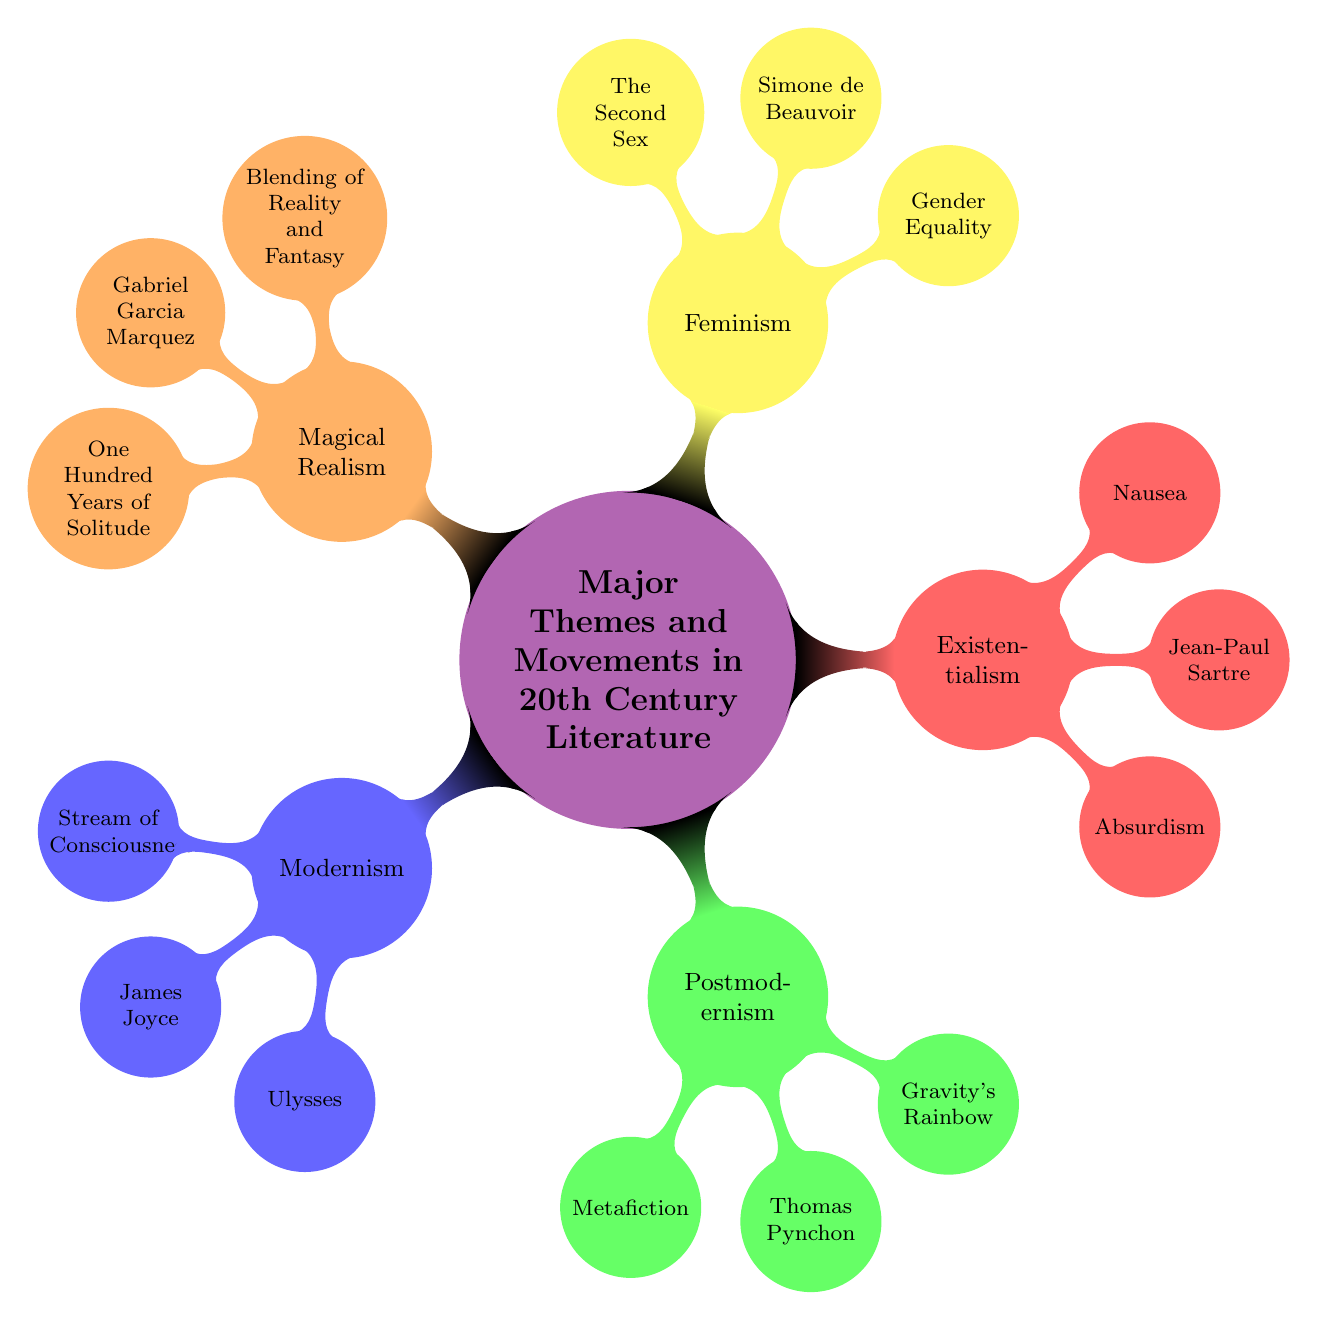What are the key features of Modernism? The diagram lists key features under the Modernism node, which include "Stream of Consciousness," "Fragmentation," and "Narrative Ambiguity."
Answer: Stream of Consciousness, Fragmentation, Narrative Ambiguity Who is a notable author of Postmodernism? The diagram shows that notable authors under Postmodernism include "Thomas Pynchon," "Don DeLillo," and "Kurt Vonnegut." Therefore, any of these can be a correct answer.
Answer: Thomas Pynchon What is a major work associated with Feminism? Within the Feminism node, the diagram lists major works which include "The Second Sex," "The Bell Jar," and "Beloved." Any of these would be a valid answer.
Answer: The Second Sex How many key features are listed under Existentialism? The Existentialism node features three key points: "Absurdism," "Freedom and Choice," and "Alienation." Therefore, the answer is determined by counting these features.
Answer: 3 Which author is associated with Magical Realism? By examining the Magical Realism node, one can see mentioned authors including "Gabriel Garcia Marquez," "Isabel Allende," and "Salman Rushdie." Therefore, any of these authors is correct.
Answer: Gabriel Garcia Marquez What core theme links Jean-Paul Sartre and his works? By focusing on the Existentialism node and identifying Jean-Paul Sartre, we find his prominent work listed as "Nausea," which connects back to his themes of Absurdism and alienation. Thus, it's primarily centered around his philosophical perspectives.
Answer: Absurdism What is the relationship between Modernism’s key features and its notable authors? Understanding this asks for combining information: Modernism includes features like "Stream of Consciousness" and is represented by authors like "James Joyce" who is critically known for using such techniques in "Ulysses." Thus, the connection lies in how these authors embody the features through their works.
Answer: James Joyce uses Stream of Consciousness How are themes grouped in the mind map? The structure indicates that each major theme or movement in 20th century literature serves as a primary node, beneath which details such as key features, notable authors, and major works are organized in a hierarchical manner, illustrating a clear category relationship.
Answer: By major themes with subcategories 